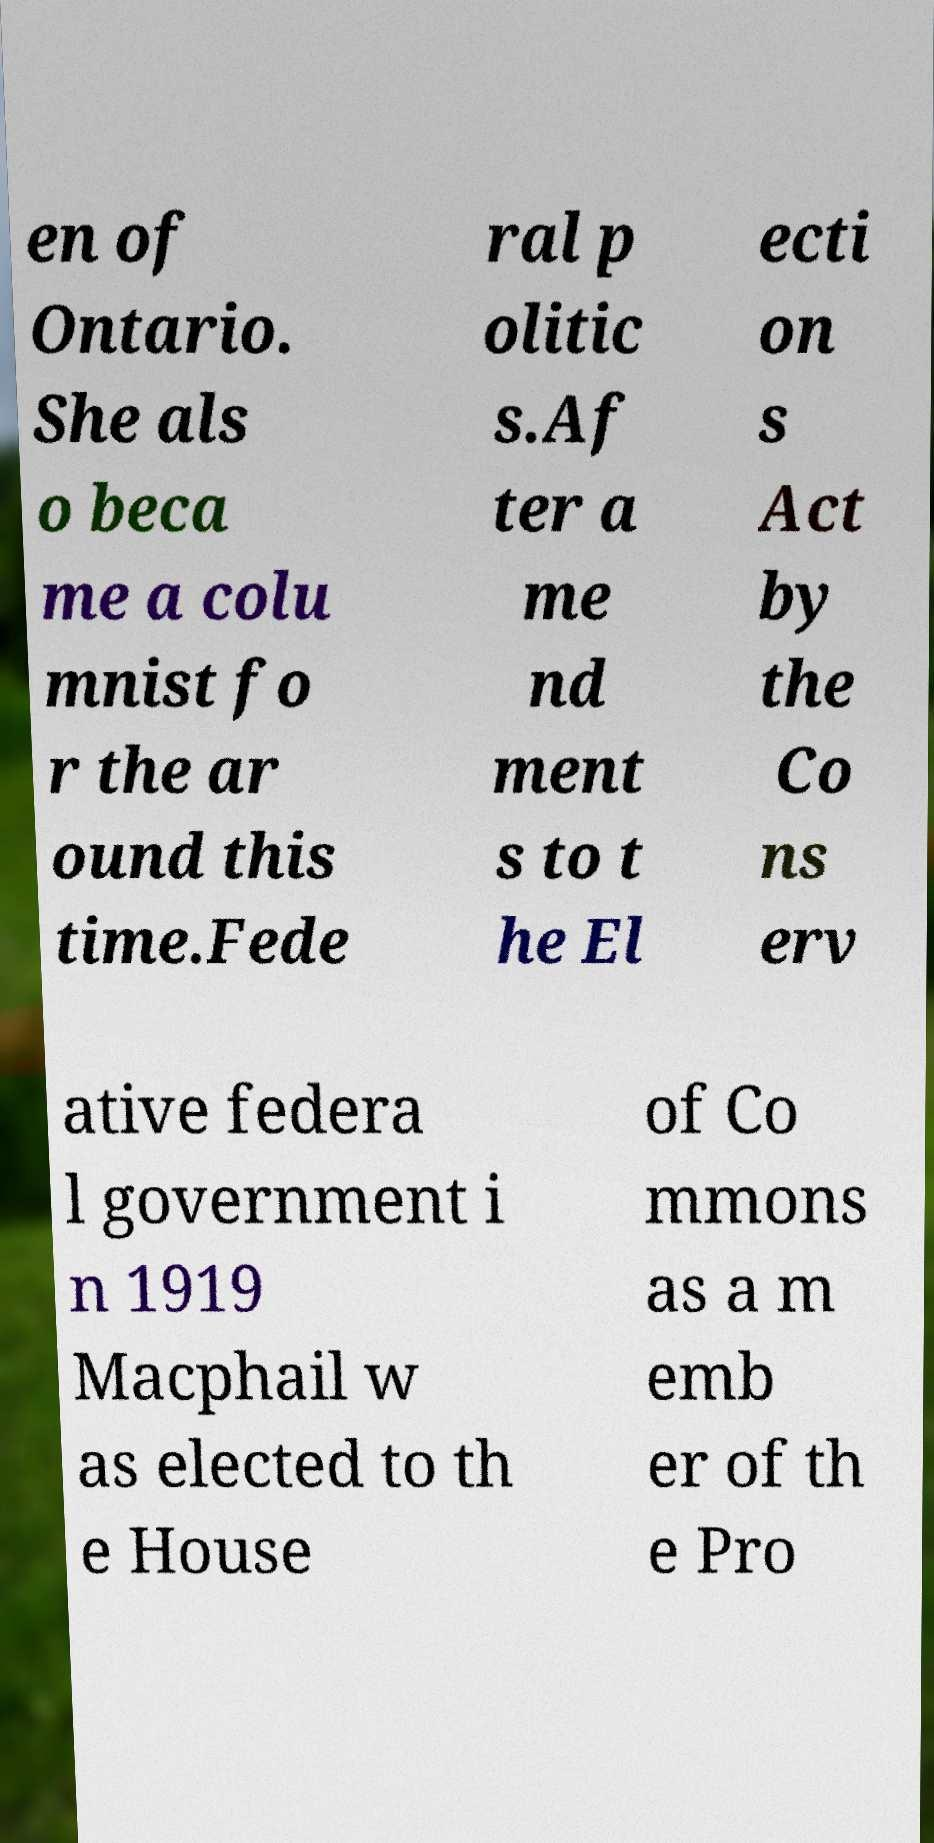Could you extract and type out the text from this image? en of Ontario. She als o beca me a colu mnist fo r the ar ound this time.Fede ral p olitic s.Af ter a me nd ment s to t he El ecti on s Act by the Co ns erv ative federa l government i n 1919 Macphail w as elected to th e House of Co mmons as a m emb er of th e Pro 